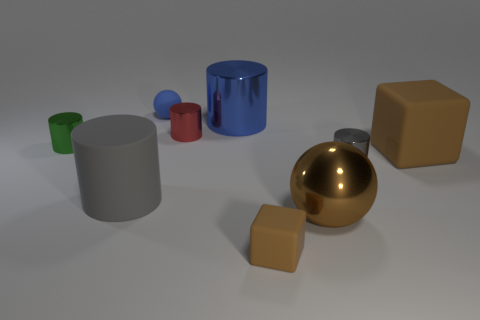Does the large block have the same color as the shiny ball?
Keep it short and to the point. Yes. What is the shape of the metal object that is the same color as the small cube?
Provide a short and direct response. Sphere. There is another thing that is the same shape as the big brown rubber thing; what is its material?
Provide a succinct answer. Rubber. What number of other objects are there of the same size as the red cylinder?
Give a very brief answer. 4. There is another block that is the same color as the large matte cube; what is its size?
Provide a short and direct response. Small. There is a big metallic object to the left of the tiny brown block; is its shape the same as the tiny gray metal thing?
Your response must be concise. Yes. How many other objects are there of the same shape as the blue rubber object?
Give a very brief answer. 1. There is a tiny shiny thing that is in front of the large cube; what shape is it?
Your response must be concise. Cylinder. Are there any other blue balls that have the same material as the big ball?
Offer a terse response. No. There is a big matte object that is to the right of the small blue ball; is it the same color as the large metallic sphere?
Provide a succinct answer. Yes. 